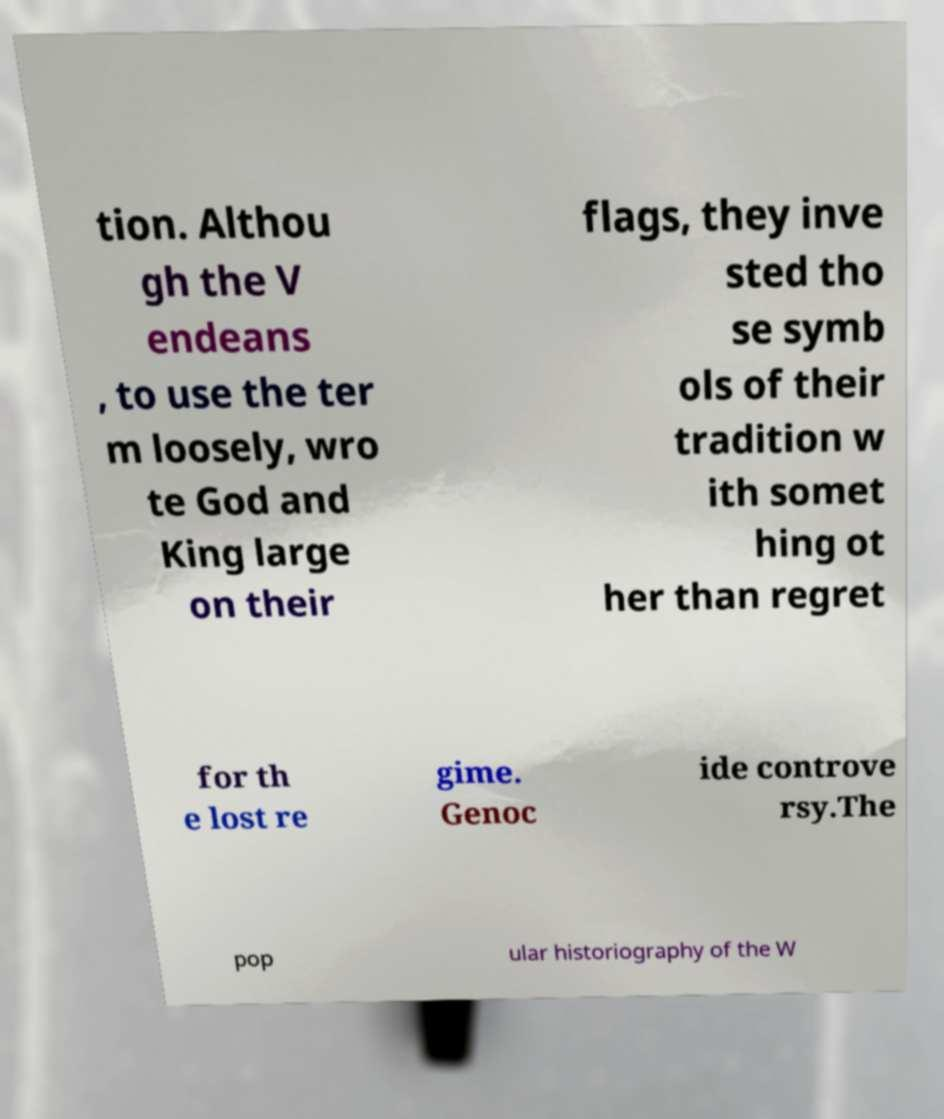Can you read and provide the text displayed in the image?This photo seems to have some interesting text. Can you extract and type it out for me? tion. Althou gh the V endeans , to use the ter m loosely, wro te God and King large on their flags, they inve sted tho se symb ols of their tradition w ith somet hing ot her than regret for th e lost re gime. Genoc ide controve rsy.The pop ular historiography of the W 